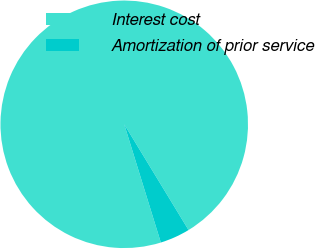Convert chart. <chart><loc_0><loc_0><loc_500><loc_500><pie_chart><fcel>Interest cost<fcel>Amortization of prior service<nl><fcel>96.08%<fcel>3.92%<nl></chart> 